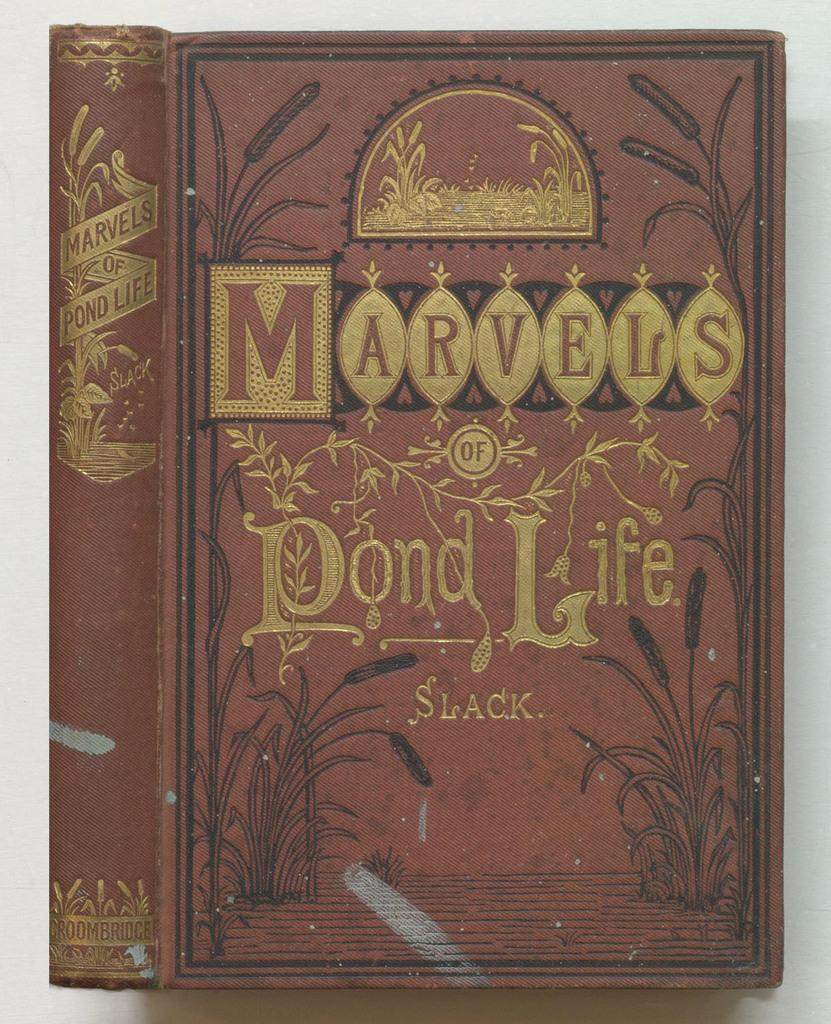<image>
Present a compact description of the photo's key features. The hardback book is old and titled 'Marvels of Pond Life'. 